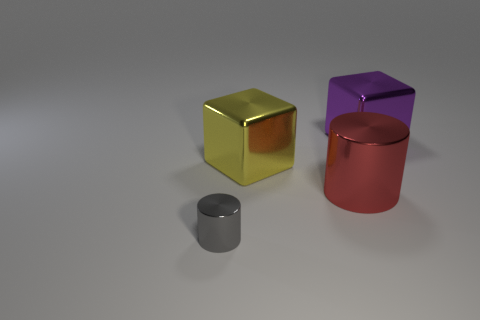Add 2 big green rubber cylinders. How many objects exist? 6 Subtract 1 blocks. How many blocks are left? 1 Subtract all big red metallic balls. Subtract all purple shiny things. How many objects are left? 3 Add 1 yellow objects. How many yellow objects are left? 2 Add 1 tiny purple cylinders. How many tiny purple cylinders exist? 1 Subtract 0 blue cubes. How many objects are left? 4 Subtract all cyan cylinders. Subtract all blue blocks. How many cylinders are left? 2 